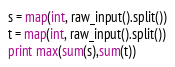<code> <loc_0><loc_0><loc_500><loc_500><_Python_>s = map(int, raw_input().split())
t = map(int, raw_input().split())
print max(sum(s),sum(t))</code> 